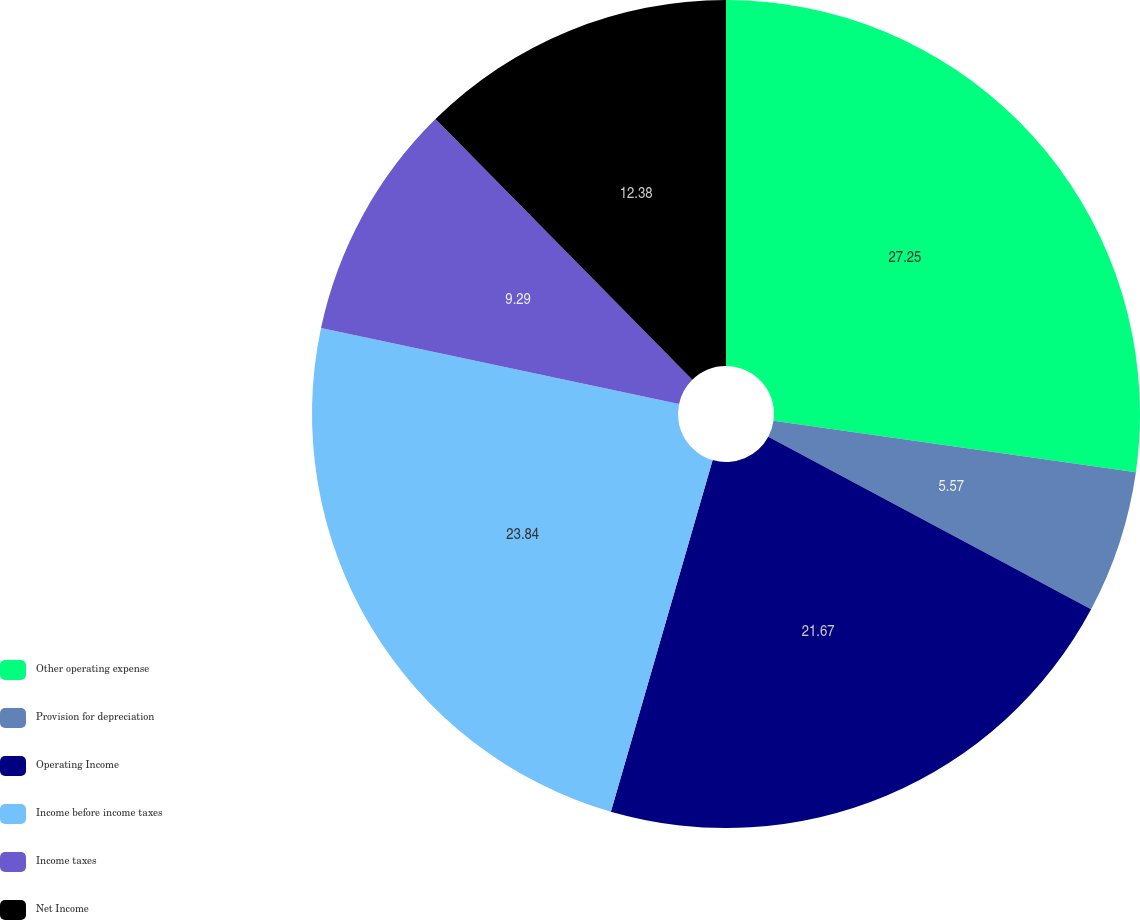Convert chart to OTSL. <chart><loc_0><loc_0><loc_500><loc_500><pie_chart><fcel>Other operating expense<fcel>Provision for depreciation<fcel>Operating Income<fcel>Income before income taxes<fcel>Income taxes<fcel>Net Income<nl><fcel>27.24%<fcel>5.57%<fcel>21.67%<fcel>23.84%<fcel>9.29%<fcel>12.38%<nl></chart> 